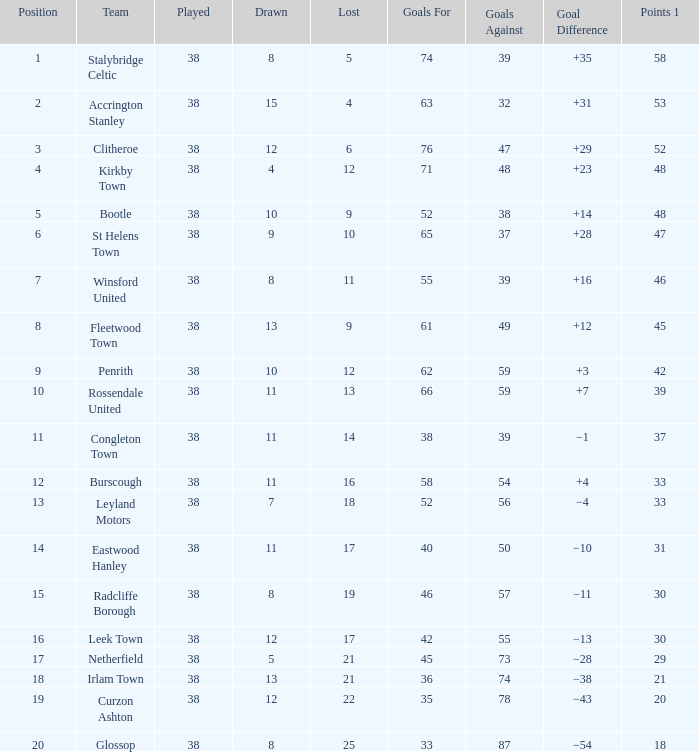What is the total number drawn with goals against less than 55, and a total of 14 losses? 1.0. 